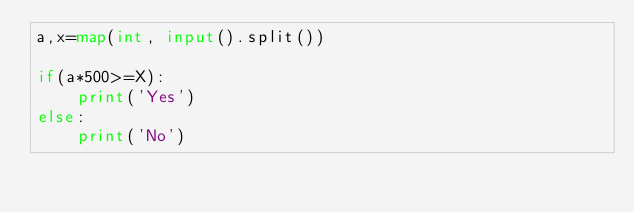<code> <loc_0><loc_0><loc_500><loc_500><_Python_>a,x=map(int, input().split())

if(a*500>=X):
    print('Yes')
else:
    print('No')
</code> 